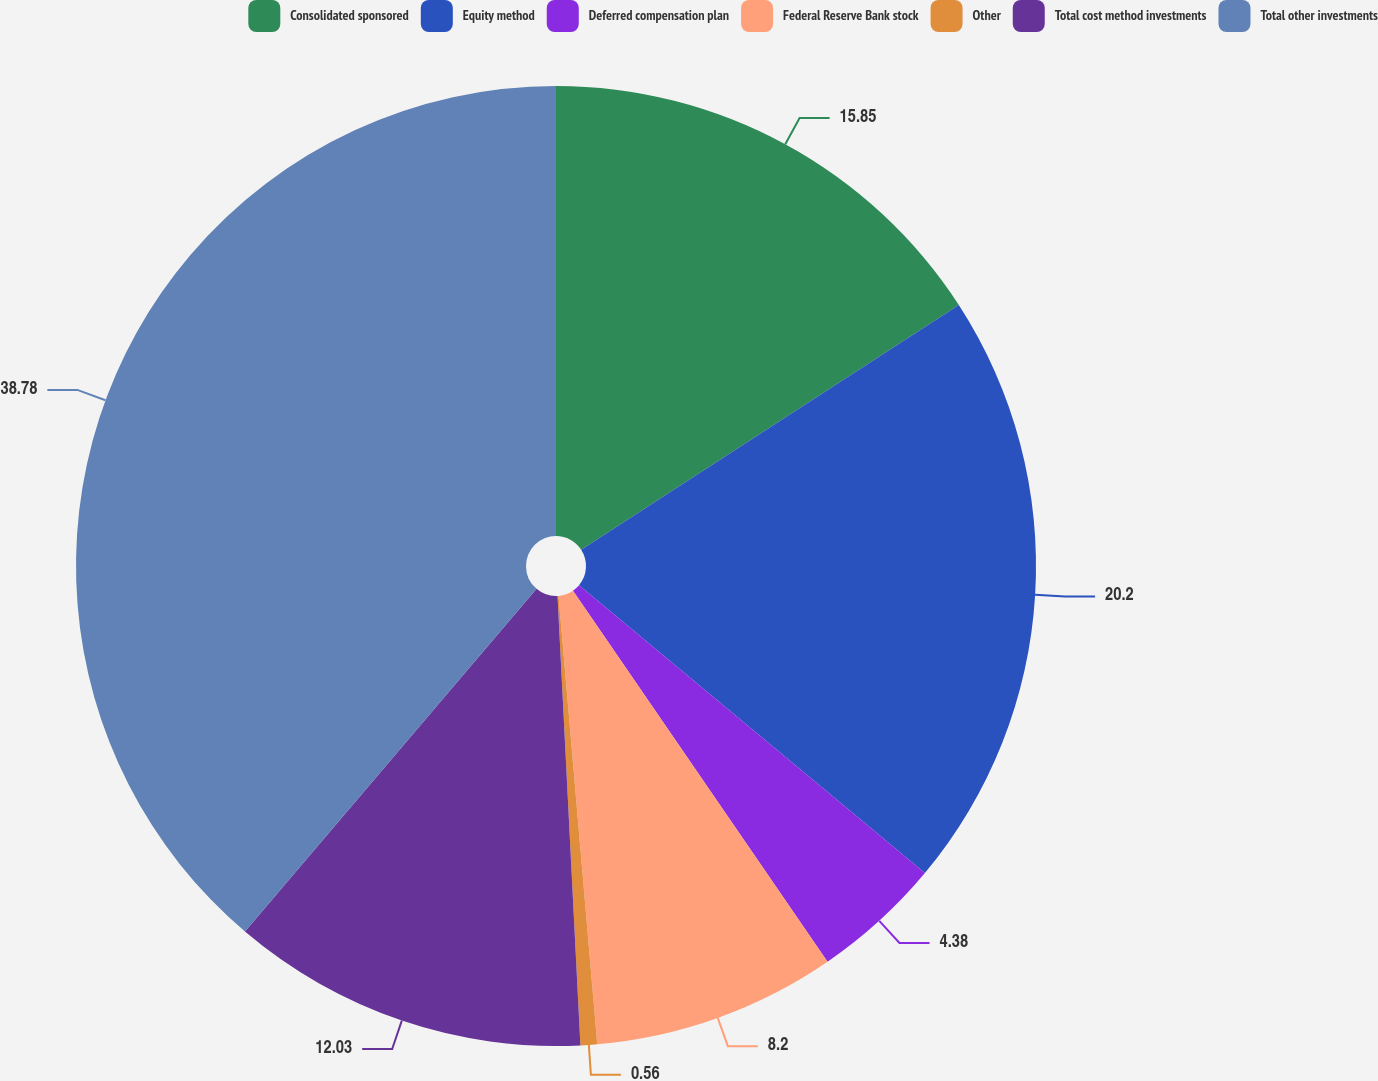Convert chart to OTSL. <chart><loc_0><loc_0><loc_500><loc_500><pie_chart><fcel>Consolidated sponsored<fcel>Equity method<fcel>Deferred compensation plan<fcel>Federal Reserve Bank stock<fcel>Other<fcel>Total cost method investments<fcel>Total other investments<nl><fcel>15.85%<fcel>20.2%<fcel>4.38%<fcel>8.2%<fcel>0.56%<fcel>12.03%<fcel>38.78%<nl></chart> 